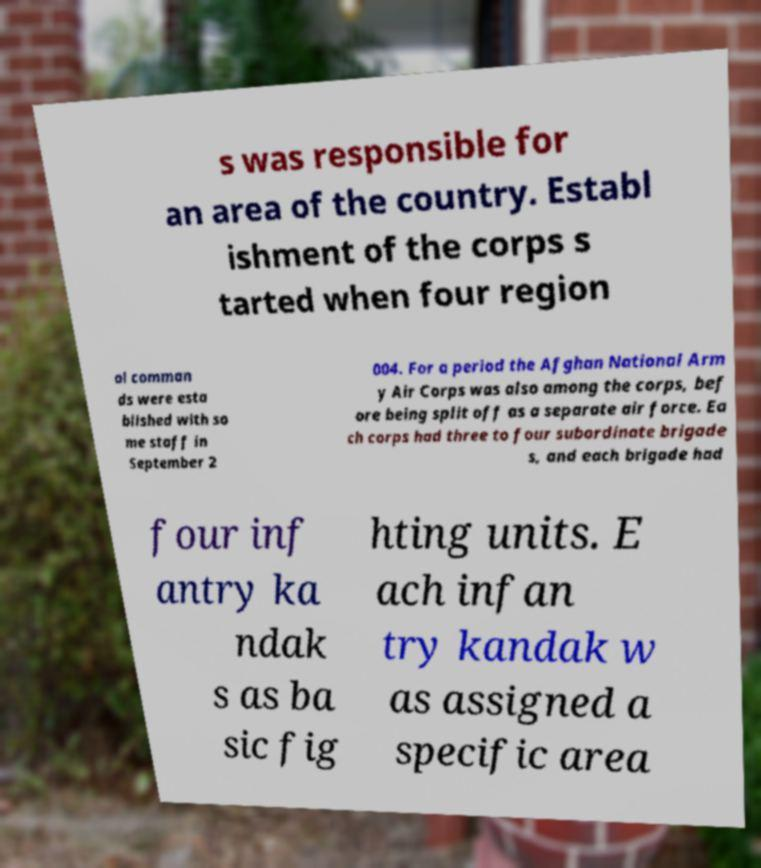There's text embedded in this image that I need extracted. Can you transcribe it verbatim? s was responsible for an area of the country. Establ ishment of the corps s tarted when four region al comman ds were esta blished with so me staff in September 2 004. For a period the Afghan National Arm y Air Corps was also among the corps, bef ore being split off as a separate air force. Ea ch corps had three to four subordinate brigade s, and each brigade had four inf antry ka ndak s as ba sic fig hting units. E ach infan try kandak w as assigned a specific area 